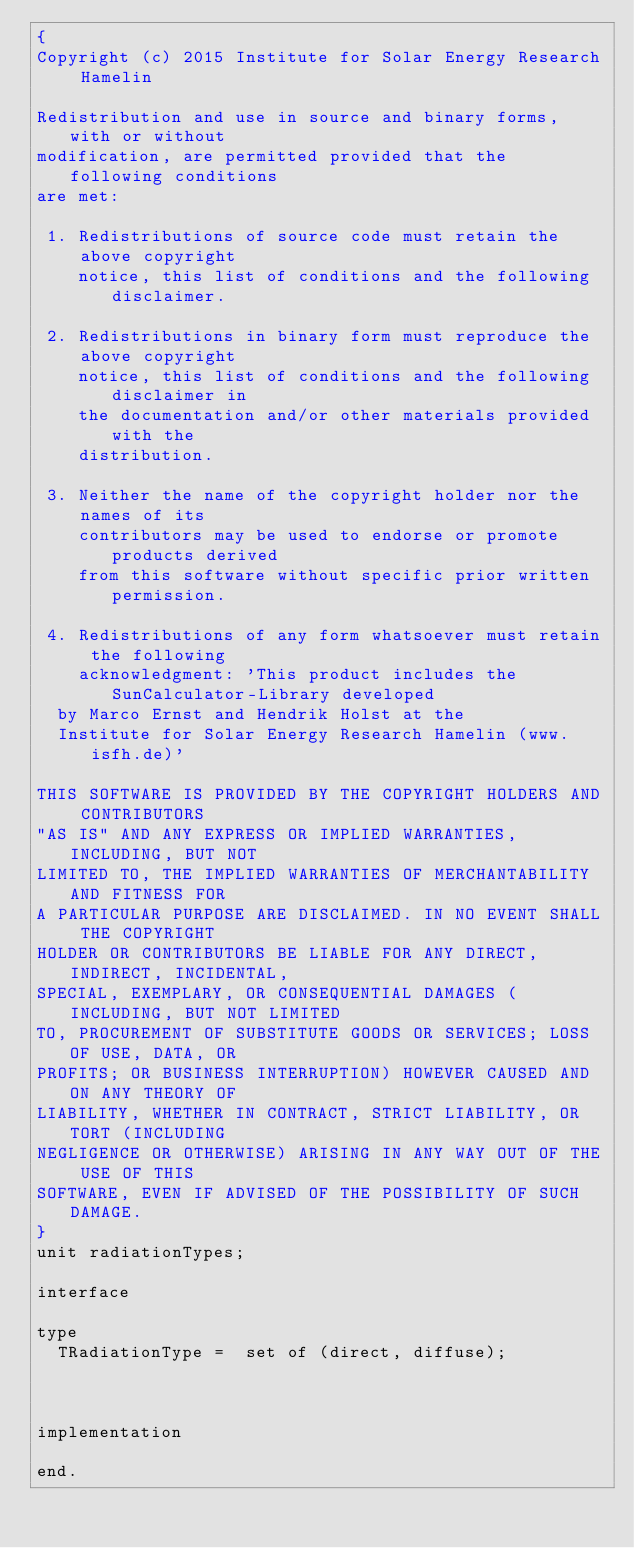<code> <loc_0><loc_0><loc_500><loc_500><_Pascal_>{
Copyright (c) 2015 Institute for Solar Energy Research Hamelin

Redistribution and use in source and binary forms, with or without
modification, are permitted provided that the following conditions
are met:

 1. Redistributions of source code must retain the above copyright
    notice, this list of conditions and the following disclaimer.

 2. Redistributions in binary form must reproduce the above copyright
    notice, this list of conditions and the following disclaimer in
    the documentation and/or other materials provided with the
    distribution.

 3. Neither the name of the copyright holder nor the names of its
    contributors may be used to endorse or promote products derived
    from this software without specific prior written permission.

 4. Redistributions of any form whatsoever must retain the following
    acknowledgment: 'This product includes the SunCalculator-Library developed 
	by Marco Ernst and Hendrik Holst at the 
	Institute for Solar Energy Research Hamelin (www.isfh.de)'
	
THIS SOFTWARE IS PROVIDED BY THE COPYRIGHT HOLDERS AND CONTRIBUTORS
"AS IS" AND ANY EXPRESS OR IMPLIED WARRANTIES, INCLUDING, BUT NOT
LIMITED TO, THE IMPLIED WARRANTIES OF MERCHANTABILITY AND FITNESS FOR
A PARTICULAR PURPOSE ARE DISCLAIMED. IN NO EVENT SHALL THE COPYRIGHT
HOLDER OR CONTRIBUTORS BE LIABLE FOR ANY DIRECT, INDIRECT, INCIDENTAL,
SPECIAL, EXEMPLARY, OR CONSEQUENTIAL DAMAGES (INCLUDING, BUT NOT LIMITED
TO, PROCUREMENT OF SUBSTITUTE GOODS OR SERVICES; LOSS OF USE, DATA, OR
PROFITS; OR BUSINESS INTERRUPTION) HOWEVER CAUSED AND ON ANY THEORY OF
LIABILITY, WHETHER IN CONTRACT, STRICT LIABILITY, OR TORT (INCLUDING
NEGLIGENCE OR OTHERWISE) ARISING IN ANY WAY OUT OF THE USE OF THIS
SOFTWARE, EVEN IF ADVISED OF THE POSSIBILITY OF SUCH DAMAGE.
}
unit radiationTypes;

interface

type
  TRadiationType =  set of (direct, diffuse);

 
  
implementation

end.
</code> 